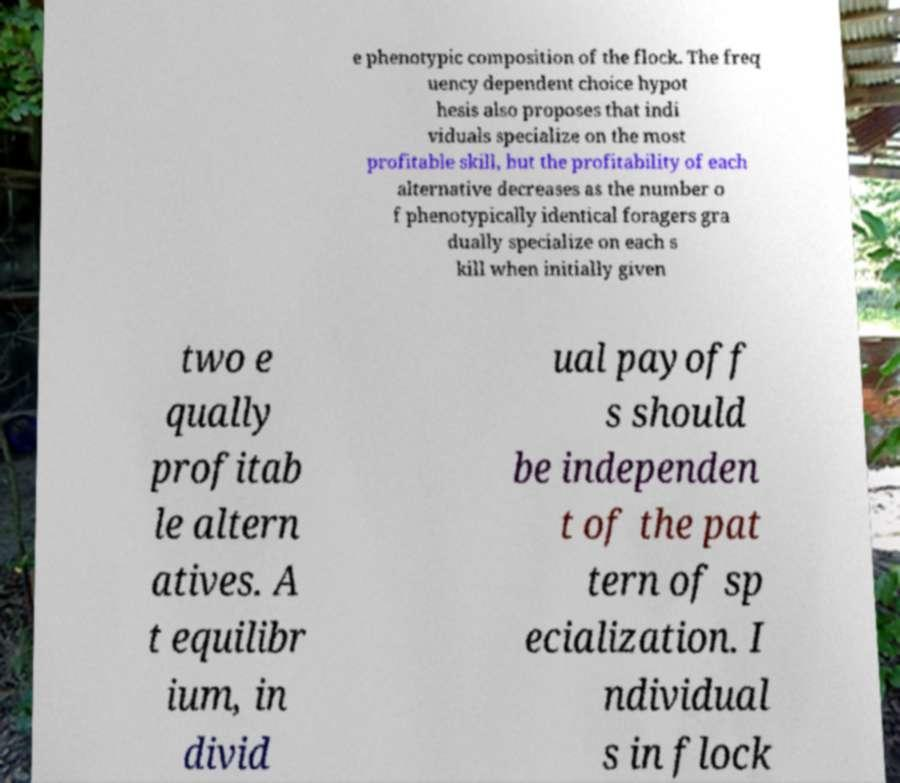I need the written content from this picture converted into text. Can you do that? e phenotypic composition of the flock. The freq uency dependent choice hypot hesis also proposes that indi viduals specialize on the most profitable skill, but the profitability of each alternative decreases as the number o f phenotypically identical foragers gra dually specialize on each s kill when initially given two e qually profitab le altern atives. A t equilibr ium, in divid ual payoff s should be independen t of the pat tern of sp ecialization. I ndividual s in flock 